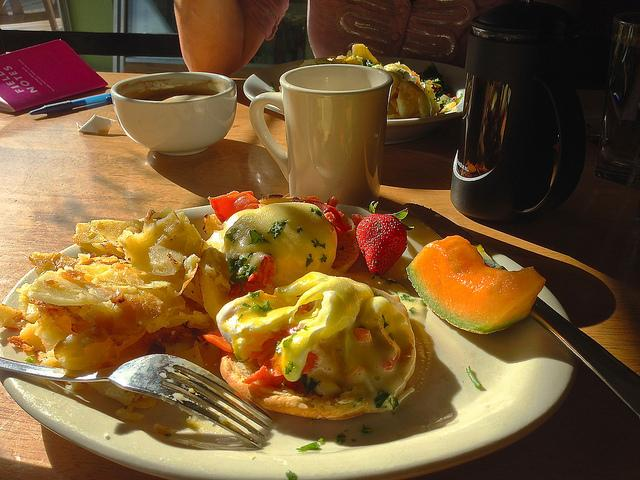What is the yellow sauce's name in the culinary world? hollandaise 